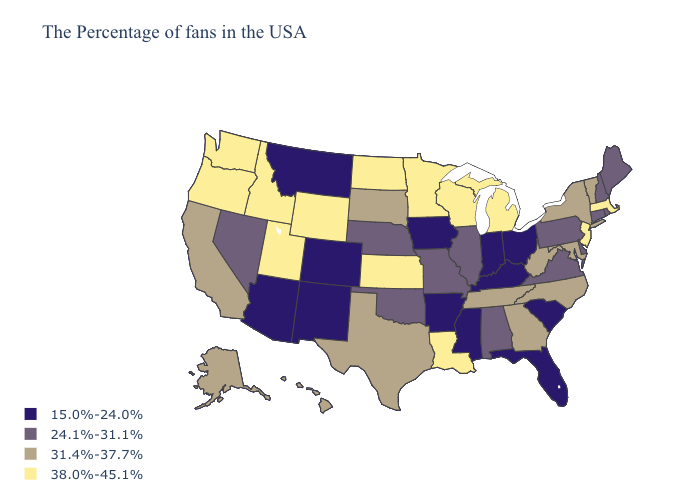What is the value of Arkansas?
Quick response, please. 15.0%-24.0%. Name the states that have a value in the range 38.0%-45.1%?
Write a very short answer. Massachusetts, New Jersey, Michigan, Wisconsin, Louisiana, Minnesota, Kansas, North Dakota, Wyoming, Utah, Idaho, Washington, Oregon. Does Florida have the lowest value in the USA?
Keep it brief. Yes. Among the states that border Florida , which have the lowest value?
Answer briefly. Alabama. What is the value of Connecticut?
Write a very short answer. 24.1%-31.1%. What is the lowest value in the USA?
Keep it brief. 15.0%-24.0%. Name the states that have a value in the range 15.0%-24.0%?
Keep it brief. South Carolina, Ohio, Florida, Kentucky, Indiana, Mississippi, Arkansas, Iowa, Colorado, New Mexico, Montana, Arizona. What is the highest value in states that border North Dakota?
Give a very brief answer. 38.0%-45.1%. Which states have the lowest value in the West?
Short answer required. Colorado, New Mexico, Montana, Arizona. Name the states that have a value in the range 31.4%-37.7%?
Answer briefly. Vermont, New York, Maryland, North Carolina, West Virginia, Georgia, Tennessee, Texas, South Dakota, California, Alaska, Hawaii. What is the value of New Mexico?
Write a very short answer. 15.0%-24.0%. What is the lowest value in the South?
Be succinct. 15.0%-24.0%. Does New Hampshire have the highest value in the Northeast?
Quick response, please. No. Does Nevada have the same value as Missouri?
Give a very brief answer. Yes. 